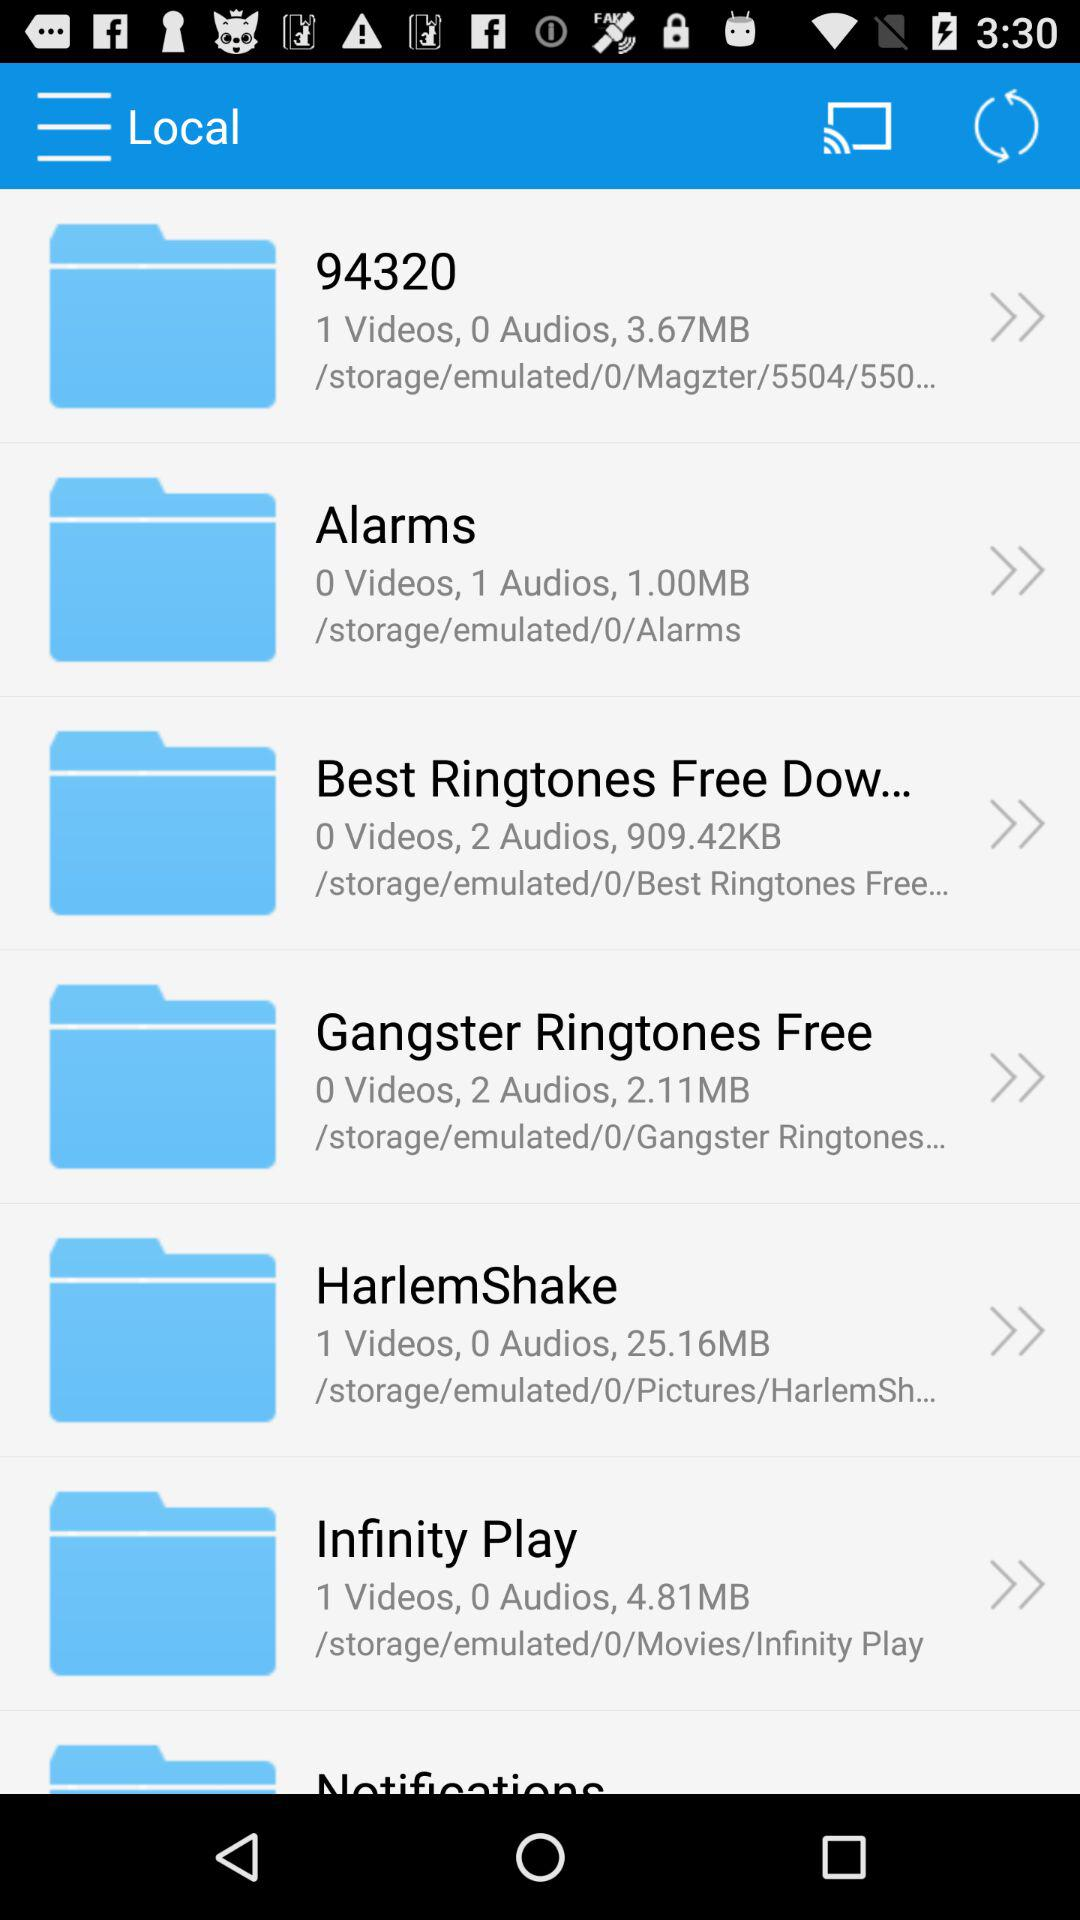What is the size of the "Alarms" folder? The size of the "Alarms" folder is 1 MB. 